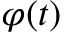<formula> <loc_0><loc_0><loc_500><loc_500>\varphi ( t )</formula> 